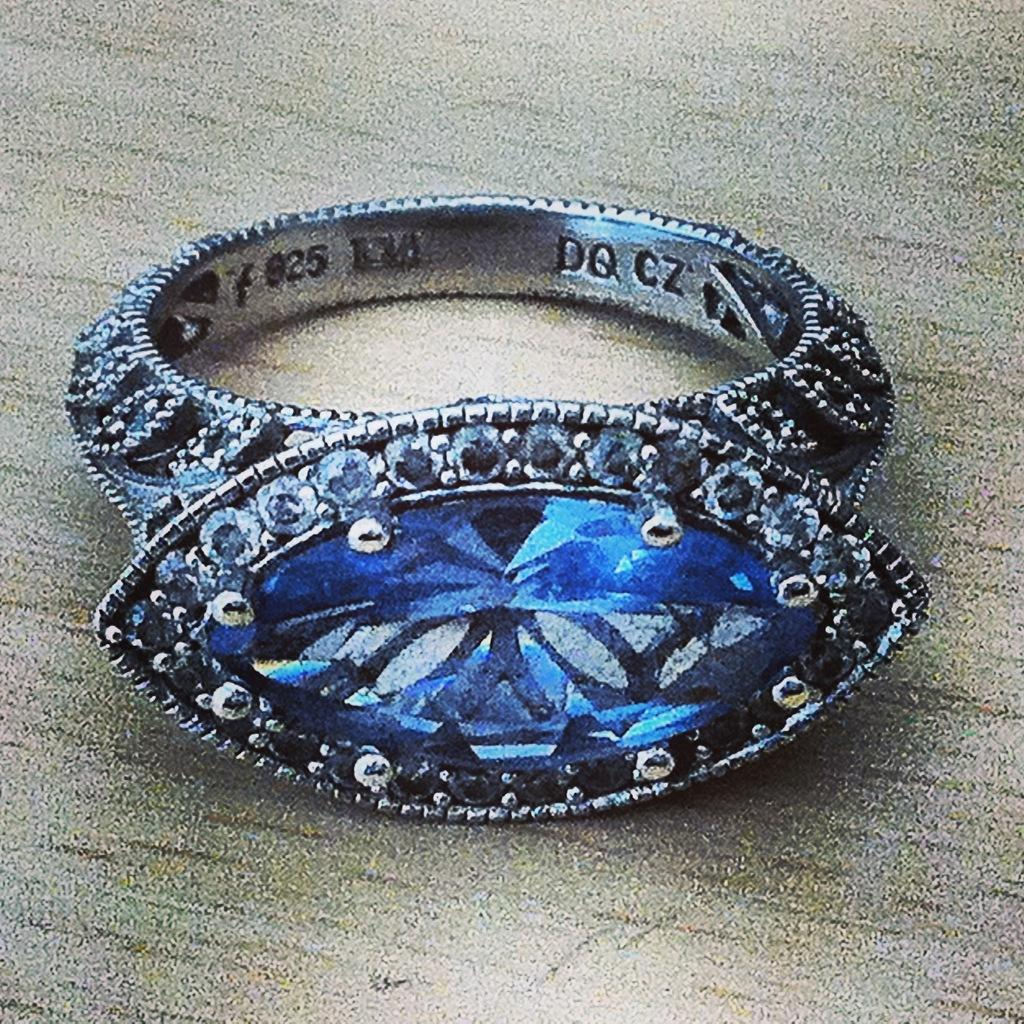What is floating on the surface of the water in the image? There is a ring on the surface of the water. What can be seen on the ring? There is some information visible on the ring. What type of food is the cook preparing in the image? There is no cook or food preparation visible in the image; it only features a ring on the water. What type of order is being processed in the image? There is no order or indication of any transaction in the image; it only features a ring on the water. 